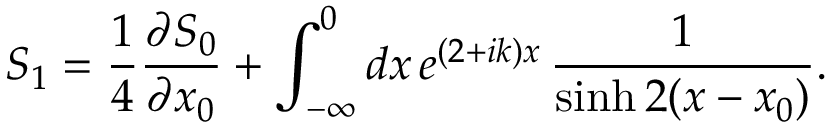Convert formula to latex. <formula><loc_0><loc_0><loc_500><loc_500>S _ { 1 } = \frac { 1 } { 4 } \frac { \partial S _ { 0 } } { \partial x _ { 0 } } + \int _ { - \infty } ^ { 0 } d x \, e ^ { ( 2 + i k ) x } \, \frac { 1 } { \sinh 2 ( x - x _ { 0 } ) } .</formula> 